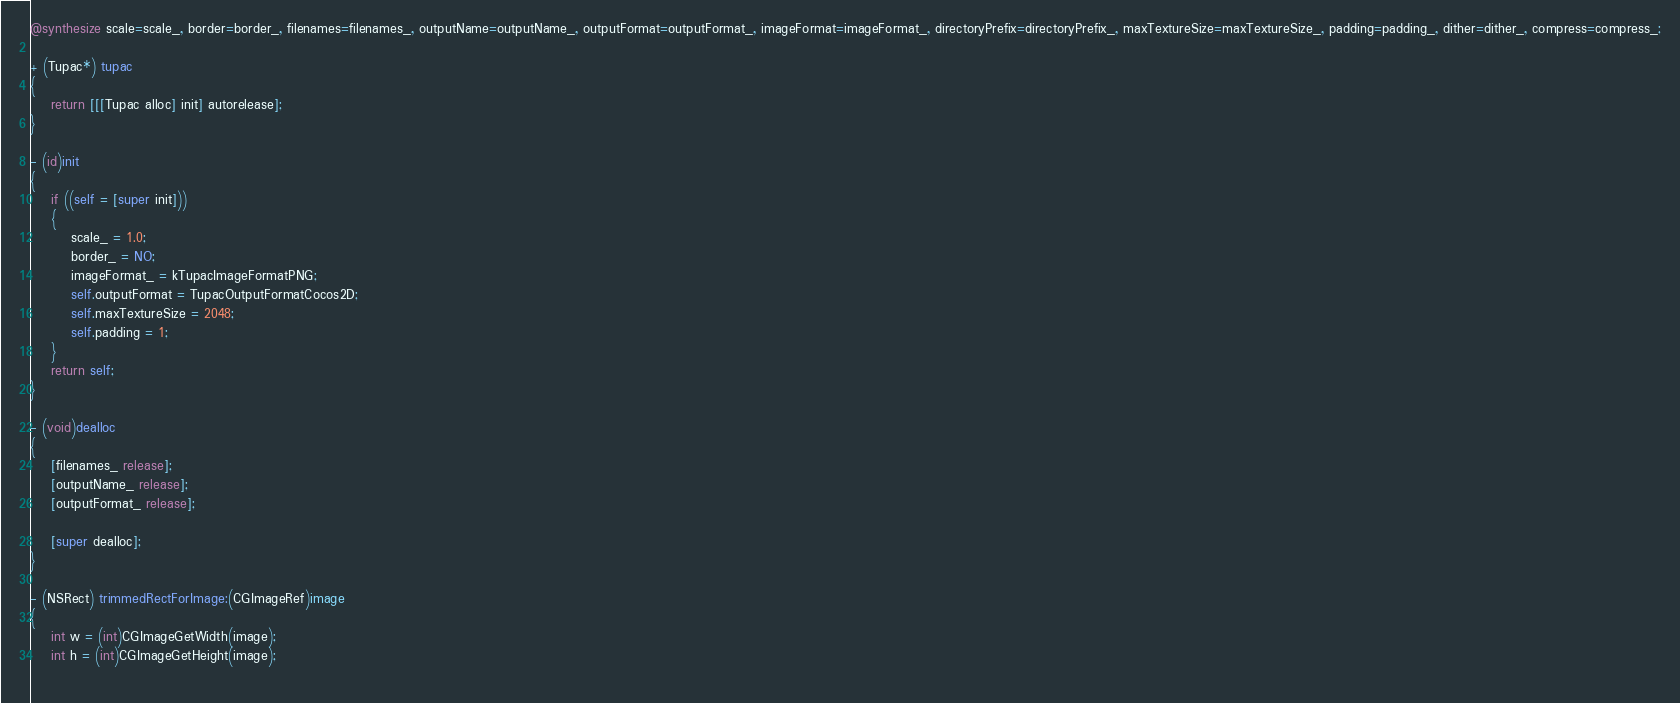Convert code to text. <code><loc_0><loc_0><loc_500><loc_500><_ObjectiveC_>@synthesize scale=scale_, border=border_, filenames=filenames_, outputName=outputName_, outputFormat=outputFormat_, imageFormat=imageFormat_, directoryPrefix=directoryPrefix_, maxTextureSize=maxTextureSize_, padding=padding_, dither=dither_, compress=compress_;

+ (Tupac*) tupac
{
    return [[[Tupac alloc] init] autorelease];
}

- (id)init
{
    if ((self = [super init]))
    {
        scale_ = 1.0;
        border_ = NO;
        imageFormat_ = kTupacImageFormatPNG;
        self.outputFormat = TupacOutputFormatCocos2D;
        self.maxTextureSize = 2048;
        self.padding = 1;
    }
    return self;
}

- (void)dealloc
{
    [filenames_ release];
    [outputName_ release];
    [outputFormat_ release];
    
    [super dealloc];
}

- (NSRect) trimmedRectForImage:(CGImageRef)image
{
    int w = (int)CGImageGetWidth(image);
    int h = (int)CGImageGetHeight(image);
    </code> 